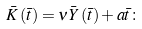Convert formula to latex. <formula><loc_0><loc_0><loc_500><loc_500>\bar { K } \left ( \bar { t } \right ) = \nu \bar { Y } \left ( \bar { t } \right ) + a \bar { t } \colon</formula> 